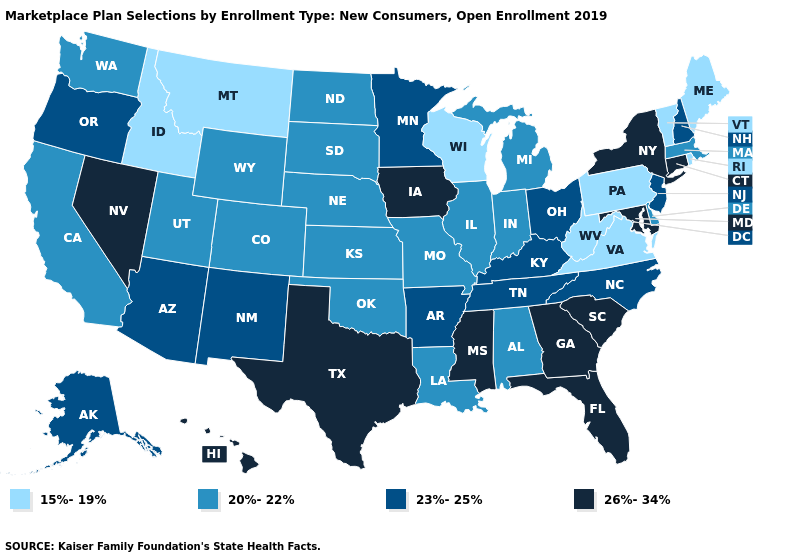Name the states that have a value in the range 26%-34%?
Short answer required. Connecticut, Florida, Georgia, Hawaii, Iowa, Maryland, Mississippi, Nevada, New York, South Carolina, Texas. Name the states that have a value in the range 20%-22%?
Answer briefly. Alabama, California, Colorado, Delaware, Illinois, Indiana, Kansas, Louisiana, Massachusetts, Michigan, Missouri, Nebraska, North Dakota, Oklahoma, South Dakota, Utah, Washington, Wyoming. Does the map have missing data?
Answer briefly. No. Does Mississippi have the highest value in the USA?
Short answer required. Yes. Among the states that border Missouri , does Tennessee have the highest value?
Give a very brief answer. No. What is the value of Idaho?
Give a very brief answer. 15%-19%. Among the states that border Arizona , which have the lowest value?
Quick response, please. California, Colorado, Utah. Name the states that have a value in the range 20%-22%?
Be succinct. Alabama, California, Colorado, Delaware, Illinois, Indiana, Kansas, Louisiana, Massachusetts, Michigan, Missouri, Nebraska, North Dakota, Oklahoma, South Dakota, Utah, Washington, Wyoming. Name the states that have a value in the range 20%-22%?
Be succinct. Alabama, California, Colorado, Delaware, Illinois, Indiana, Kansas, Louisiana, Massachusetts, Michigan, Missouri, Nebraska, North Dakota, Oklahoma, South Dakota, Utah, Washington, Wyoming. Name the states that have a value in the range 20%-22%?
Short answer required. Alabama, California, Colorado, Delaware, Illinois, Indiana, Kansas, Louisiana, Massachusetts, Michigan, Missouri, Nebraska, North Dakota, Oklahoma, South Dakota, Utah, Washington, Wyoming. Name the states that have a value in the range 15%-19%?
Quick response, please. Idaho, Maine, Montana, Pennsylvania, Rhode Island, Vermont, Virginia, West Virginia, Wisconsin. Among the states that border Washington , which have the highest value?
Quick response, please. Oregon. Which states have the lowest value in the Northeast?
Be succinct. Maine, Pennsylvania, Rhode Island, Vermont. Which states have the highest value in the USA?
Answer briefly. Connecticut, Florida, Georgia, Hawaii, Iowa, Maryland, Mississippi, Nevada, New York, South Carolina, Texas. Among the states that border Tennessee , which have the highest value?
Short answer required. Georgia, Mississippi. 